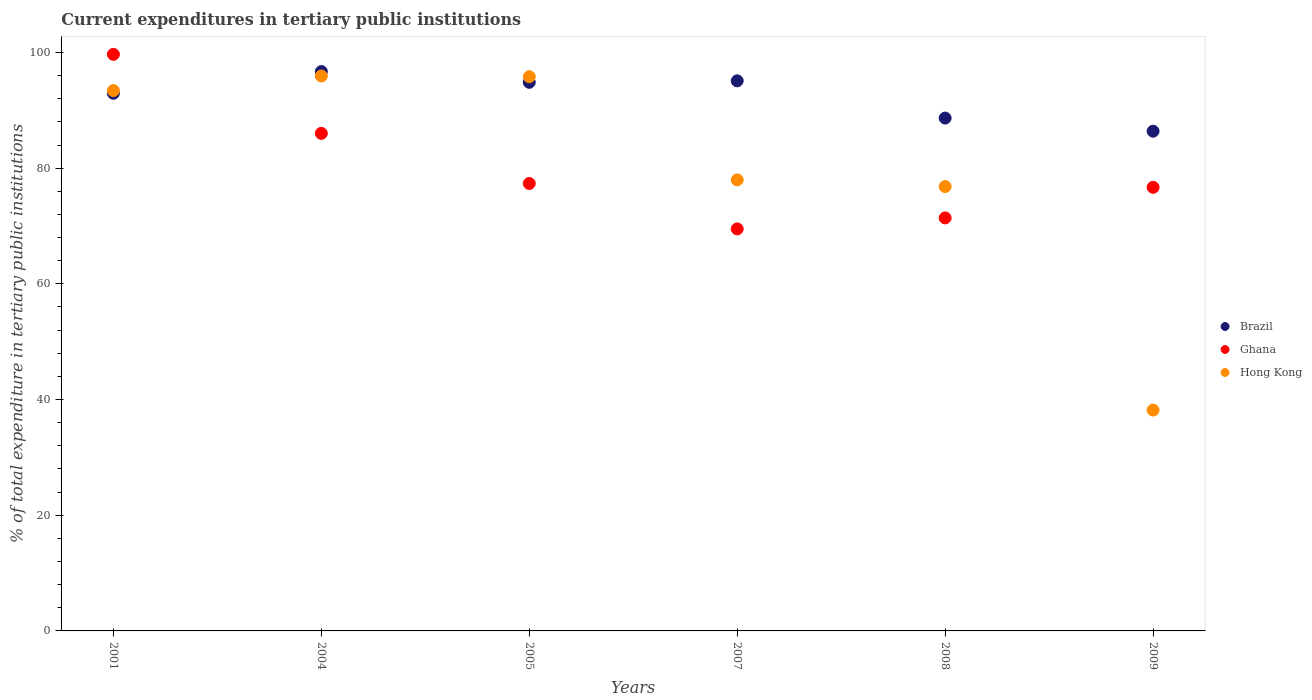What is the current expenditures in tertiary public institutions in Brazil in 2009?
Keep it short and to the point. 86.39. Across all years, what is the maximum current expenditures in tertiary public institutions in Ghana?
Offer a terse response. 99.67. Across all years, what is the minimum current expenditures in tertiary public institutions in Hong Kong?
Provide a short and direct response. 38.18. In which year was the current expenditures in tertiary public institutions in Brazil maximum?
Offer a terse response. 2004. In which year was the current expenditures in tertiary public institutions in Brazil minimum?
Ensure brevity in your answer.  2009. What is the total current expenditures in tertiary public institutions in Brazil in the graph?
Your answer should be very brief. 554.61. What is the difference between the current expenditures in tertiary public institutions in Ghana in 2004 and that in 2008?
Make the answer very short. 14.61. What is the difference between the current expenditures in tertiary public institutions in Hong Kong in 2008 and the current expenditures in tertiary public institutions in Brazil in 2009?
Ensure brevity in your answer.  -9.57. What is the average current expenditures in tertiary public institutions in Ghana per year?
Give a very brief answer. 80.1. In the year 2004, what is the difference between the current expenditures in tertiary public institutions in Hong Kong and current expenditures in tertiary public institutions in Ghana?
Your response must be concise. 9.92. In how many years, is the current expenditures in tertiary public institutions in Hong Kong greater than 28 %?
Your answer should be compact. 6. What is the ratio of the current expenditures in tertiary public institutions in Hong Kong in 2004 to that in 2007?
Make the answer very short. 1.23. Is the current expenditures in tertiary public institutions in Hong Kong in 2001 less than that in 2007?
Your answer should be very brief. No. Is the difference between the current expenditures in tertiary public institutions in Hong Kong in 2001 and 2004 greater than the difference between the current expenditures in tertiary public institutions in Ghana in 2001 and 2004?
Offer a very short reply. No. What is the difference between the highest and the second highest current expenditures in tertiary public institutions in Hong Kong?
Provide a succinct answer. 0.13. What is the difference between the highest and the lowest current expenditures in tertiary public institutions in Hong Kong?
Offer a very short reply. 57.75. In how many years, is the current expenditures in tertiary public institutions in Brazil greater than the average current expenditures in tertiary public institutions in Brazil taken over all years?
Offer a very short reply. 4. Is the sum of the current expenditures in tertiary public institutions in Hong Kong in 2001 and 2004 greater than the maximum current expenditures in tertiary public institutions in Brazil across all years?
Keep it short and to the point. Yes. Does the current expenditures in tertiary public institutions in Hong Kong monotonically increase over the years?
Your answer should be compact. No. Is the current expenditures in tertiary public institutions in Hong Kong strictly greater than the current expenditures in tertiary public institutions in Ghana over the years?
Your answer should be compact. No. Is the current expenditures in tertiary public institutions in Hong Kong strictly less than the current expenditures in tertiary public institutions in Brazil over the years?
Keep it short and to the point. No. How many years are there in the graph?
Offer a very short reply. 6. What is the difference between two consecutive major ticks on the Y-axis?
Provide a succinct answer. 20. Does the graph contain grids?
Make the answer very short. No. How many legend labels are there?
Ensure brevity in your answer.  3. What is the title of the graph?
Keep it short and to the point. Current expenditures in tertiary public institutions. Does "New Caledonia" appear as one of the legend labels in the graph?
Ensure brevity in your answer.  No. What is the label or title of the Y-axis?
Provide a short and direct response. % of total expenditure in tertiary public institutions. What is the % of total expenditure in tertiary public institutions in Brazil in 2001?
Provide a succinct answer. 92.94. What is the % of total expenditure in tertiary public institutions of Ghana in 2001?
Your answer should be compact. 99.67. What is the % of total expenditure in tertiary public institutions of Hong Kong in 2001?
Make the answer very short. 93.41. What is the % of total expenditure in tertiary public institutions in Brazil in 2004?
Ensure brevity in your answer.  96.7. What is the % of total expenditure in tertiary public institutions in Ghana in 2004?
Provide a short and direct response. 86.01. What is the % of total expenditure in tertiary public institutions in Hong Kong in 2004?
Ensure brevity in your answer.  95.93. What is the % of total expenditure in tertiary public institutions in Brazil in 2005?
Offer a very short reply. 94.84. What is the % of total expenditure in tertiary public institutions of Ghana in 2005?
Keep it short and to the point. 77.35. What is the % of total expenditure in tertiary public institutions of Hong Kong in 2005?
Provide a short and direct response. 95.81. What is the % of total expenditure in tertiary public institutions in Brazil in 2007?
Keep it short and to the point. 95.09. What is the % of total expenditure in tertiary public institutions in Ghana in 2007?
Ensure brevity in your answer.  69.49. What is the % of total expenditure in tertiary public institutions in Hong Kong in 2007?
Provide a short and direct response. 77.98. What is the % of total expenditure in tertiary public institutions of Brazil in 2008?
Make the answer very short. 88.65. What is the % of total expenditure in tertiary public institutions in Ghana in 2008?
Give a very brief answer. 71.4. What is the % of total expenditure in tertiary public institutions of Hong Kong in 2008?
Ensure brevity in your answer.  76.82. What is the % of total expenditure in tertiary public institutions of Brazil in 2009?
Your response must be concise. 86.39. What is the % of total expenditure in tertiary public institutions in Ghana in 2009?
Ensure brevity in your answer.  76.69. What is the % of total expenditure in tertiary public institutions of Hong Kong in 2009?
Ensure brevity in your answer.  38.18. Across all years, what is the maximum % of total expenditure in tertiary public institutions in Brazil?
Make the answer very short. 96.7. Across all years, what is the maximum % of total expenditure in tertiary public institutions in Ghana?
Provide a succinct answer. 99.67. Across all years, what is the maximum % of total expenditure in tertiary public institutions in Hong Kong?
Your response must be concise. 95.93. Across all years, what is the minimum % of total expenditure in tertiary public institutions in Brazil?
Ensure brevity in your answer.  86.39. Across all years, what is the minimum % of total expenditure in tertiary public institutions in Ghana?
Your answer should be compact. 69.49. Across all years, what is the minimum % of total expenditure in tertiary public institutions in Hong Kong?
Your response must be concise. 38.18. What is the total % of total expenditure in tertiary public institutions of Brazil in the graph?
Give a very brief answer. 554.61. What is the total % of total expenditure in tertiary public institutions in Ghana in the graph?
Your answer should be very brief. 480.62. What is the total % of total expenditure in tertiary public institutions in Hong Kong in the graph?
Ensure brevity in your answer.  478.12. What is the difference between the % of total expenditure in tertiary public institutions in Brazil in 2001 and that in 2004?
Ensure brevity in your answer.  -3.76. What is the difference between the % of total expenditure in tertiary public institutions in Ghana in 2001 and that in 2004?
Offer a terse response. 13.66. What is the difference between the % of total expenditure in tertiary public institutions of Hong Kong in 2001 and that in 2004?
Make the answer very short. -2.53. What is the difference between the % of total expenditure in tertiary public institutions of Brazil in 2001 and that in 2005?
Give a very brief answer. -1.9. What is the difference between the % of total expenditure in tertiary public institutions of Ghana in 2001 and that in 2005?
Your answer should be very brief. 22.32. What is the difference between the % of total expenditure in tertiary public institutions in Hong Kong in 2001 and that in 2005?
Your answer should be very brief. -2.4. What is the difference between the % of total expenditure in tertiary public institutions of Brazil in 2001 and that in 2007?
Offer a very short reply. -2.15. What is the difference between the % of total expenditure in tertiary public institutions of Ghana in 2001 and that in 2007?
Your answer should be very brief. 30.18. What is the difference between the % of total expenditure in tertiary public institutions of Hong Kong in 2001 and that in 2007?
Provide a short and direct response. 15.43. What is the difference between the % of total expenditure in tertiary public institutions in Brazil in 2001 and that in 2008?
Make the answer very short. 4.29. What is the difference between the % of total expenditure in tertiary public institutions of Ghana in 2001 and that in 2008?
Offer a very short reply. 28.27. What is the difference between the % of total expenditure in tertiary public institutions of Hong Kong in 2001 and that in 2008?
Your answer should be very brief. 16.59. What is the difference between the % of total expenditure in tertiary public institutions in Brazil in 2001 and that in 2009?
Offer a very short reply. 6.55. What is the difference between the % of total expenditure in tertiary public institutions in Ghana in 2001 and that in 2009?
Provide a succinct answer. 22.98. What is the difference between the % of total expenditure in tertiary public institutions of Hong Kong in 2001 and that in 2009?
Your answer should be compact. 55.22. What is the difference between the % of total expenditure in tertiary public institutions of Brazil in 2004 and that in 2005?
Keep it short and to the point. 1.86. What is the difference between the % of total expenditure in tertiary public institutions of Ghana in 2004 and that in 2005?
Ensure brevity in your answer.  8.66. What is the difference between the % of total expenditure in tertiary public institutions of Hong Kong in 2004 and that in 2005?
Give a very brief answer. 0.13. What is the difference between the % of total expenditure in tertiary public institutions of Brazil in 2004 and that in 2007?
Provide a succinct answer. 1.6. What is the difference between the % of total expenditure in tertiary public institutions in Ghana in 2004 and that in 2007?
Your response must be concise. 16.52. What is the difference between the % of total expenditure in tertiary public institutions in Hong Kong in 2004 and that in 2007?
Offer a very short reply. 17.96. What is the difference between the % of total expenditure in tertiary public institutions of Brazil in 2004 and that in 2008?
Offer a terse response. 8.04. What is the difference between the % of total expenditure in tertiary public institutions of Ghana in 2004 and that in 2008?
Ensure brevity in your answer.  14.61. What is the difference between the % of total expenditure in tertiary public institutions of Hong Kong in 2004 and that in 2008?
Make the answer very short. 19.11. What is the difference between the % of total expenditure in tertiary public institutions of Brazil in 2004 and that in 2009?
Your answer should be compact. 10.31. What is the difference between the % of total expenditure in tertiary public institutions of Ghana in 2004 and that in 2009?
Provide a short and direct response. 9.33. What is the difference between the % of total expenditure in tertiary public institutions in Hong Kong in 2004 and that in 2009?
Your answer should be compact. 57.75. What is the difference between the % of total expenditure in tertiary public institutions in Brazil in 2005 and that in 2007?
Provide a short and direct response. -0.25. What is the difference between the % of total expenditure in tertiary public institutions in Ghana in 2005 and that in 2007?
Make the answer very short. 7.86. What is the difference between the % of total expenditure in tertiary public institutions in Hong Kong in 2005 and that in 2007?
Your answer should be compact. 17.83. What is the difference between the % of total expenditure in tertiary public institutions of Brazil in 2005 and that in 2008?
Ensure brevity in your answer.  6.18. What is the difference between the % of total expenditure in tertiary public institutions of Ghana in 2005 and that in 2008?
Ensure brevity in your answer.  5.95. What is the difference between the % of total expenditure in tertiary public institutions in Hong Kong in 2005 and that in 2008?
Your answer should be very brief. 18.99. What is the difference between the % of total expenditure in tertiary public institutions of Brazil in 2005 and that in 2009?
Keep it short and to the point. 8.45. What is the difference between the % of total expenditure in tertiary public institutions of Ghana in 2005 and that in 2009?
Ensure brevity in your answer.  0.67. What is the difference between the % of total expenditure in tertiary public institutions of Hong Kong in 2005 and that in 2009?
Give a very brief answer. 57.63. What is the difference between the % of total expenditure in tertiary public institutions of Brazil in 2007 and that in 2008?
Your answer should be compact. 6.44. What is the difference between the % of total expenditure in tertiary public institutions in Ghana in 2007 and that in 2008?
Ensure brevity in your answer.  -1.91. What is the difference between the % of total expenditure in tertiary public institutions of Hong Kong in 2007 and that in 2008?
Your answer should be compact. 1.16. What is the difference between the % of total expenditure in tertiary public institutions of Brazil in 2007 and that in 2009?
Make the answer very short. 8.71. What is the difference between the % of total expenditure in tertiary public institutions in Ghana in 2007 and that in 2009?
Make the answer very short. -7.19. What is the difference between the % of total expenditure in tertiary public institutions of Hong Kong in 2007 and that in 2009?
Give a very brief answer. 39.79. What is the difference between the % of total expenditure in tertiary public institutions in Brazil in 2008 and that in 2009?
Provide a short and direct response. 2.27. What is the difference between the % of total expenditure in tertiary public institutions in Ghana in 2008 and that in 2009?
Your response must be concise. -5.29. What is the difference between the % of total expenditure in tertiary public institutions in Hong Kong in 2008 and that in 2009?
Provide a succinct answer. 38.64. What is the difference between the % of total expenditure in tertiary public institutions of Brazil in 2001 and the % of total expenditure in tertiary public institutions of Ghana in 2004?
Make the answer very short. 6.93. What is the difference between the % of total expenditure in tertiary public institutions in Brazil in 2001 and the % of total expenditure in tertiary public institutions in Hong Kong in 2004?
Provide a succinct answer. -2.99. What is the difference between the % of total expenditure in tertiary public institutions in Ghana in 2001 and the % of total expenditure in tertiary public institutions in Hong Kong in 2004?
Offer a very short reply. 3.74. What is the difference between the % of total expenditure in tertiary public institutions of Brazil in 2001 and the % of total expenditure in tertiary public institutions of Ghana in 2005?
Ensure brevity in your answer.  15.59. What is the difference between the % of total expenditure in tertiary public institutions in Brazil in 2001 and the % of total expenditure in tertiary public institutions in Hong Kong in 2005?
Make the answer very short. -2.87. What is the difference between the % of total expenditure in tertiary public institutions of Ghana in 2001 and the % of total expenditure in tertiary public institutions of Hong Kong in 2005?
Offer a very short reply. 3.86. What is the difference between the % of total expenditure in tertiary public institutions of Brazil in 2001 and the % of total expenditure in tertiary public institutions of Ghana in 2007?
Make the answer very short. 23.45. What is the difference between the % of total expenditure in tertiary public institutions of Brazil in 2001 and the % of total expenditure in tertiary public institutions of Hong Kong in 2007?
Offer a terse response. 14.97. What is the difference between the % of total expenditure in tertiary public institutions of Ghana in 2001 and the % of total expenditure in tertiary public institutions of Hong Kong in 2007?
Provide a short and direct response. 21.7. What is the difference between the % of total expenditure in tertiary public institutions of Brazil in 2001 and the % of total expenditure in tertiary public institutions of Ghana in 2008?
Keep it short and to the point. 21.54. What is the difference between the % of total expenditure in tertiary public institutions of Brazil in 2001 and the % of total expenditure in tertiary public institutions of Hong Kong in 2008?
Your answer should be very brief. 16.12. What is the difference between the % of total expenditure in tertiary public institutions in Ghana in 2001 and the % of total expenditure in tertiary public institutions in Hong Kong in 2008?
Provide a succinct answer. 22.85. What is the difference between the % of total expenditure in tertiary public institutions of Brazil in 2001 and the % of total expenditure in tertiary public institutions of Ghana in 2009?
Provide a short and direct response. 16.25. What is the difference between the % of total expenditure in tertiary public institutions of Brazil in 2001 and the % of total expenditure in tertiary public institutions of Hong Kong in 2009?
Offer a very short reply. 54.76. What is the difference between the % of total expenditure in tertiary public institutions in Ghana in 2001 and the % of total expenditure in tertiary public institutions in Hong Kong in 2009?
Offer a very short reply. 61.49. What is the difference between the % of total expenditure in tertiary public institutions in Brazil in 2004 and the % of total expenditure in tertiary public institutions in Ghana in 2005?
Your response must be concise. 19.34. What is the difference between the % of total expenditure in tertiary public institutions of Brazil in 2004 and the % of total expenditure in tertiary public institutions of Hong Kong in 2005?
Your answer should be very brief. 0.89. What is the difference between the % of total expenditure in tertiary public institutions in Ghana in 2004 and the % of total expenditure in tertiary public institutions in Hong Kong in 2005?
Your answer should be compact. -9.79. What is the difference between the % of total expenditure in tertiary public institutions of Brazil in 2004 and the % of total expenditure in tertiary public institutions of Ghana in 2007?
Give a very brief answer. 27.2. What is the difference between the % of total expenditure in tertiary public institutions of Brazil in 2004 and the % of total expenditure in tertiary public institutions of Hong Kong in 2007?
Make the answer very short. 18.72. What is the difference between the % of total expenditure in tertiary public institutions in Ghana in 2004 and the % of total expenditure in tertiary public institutions in Hong Kong in 2007?
Keep it short and to the point. 8.04. What is the difference between the % of total expenditure in tertiary public institutions in Brazil in 2004 and the % of total expenditure in tertiary public institutions in Ghana in 2008?
Offer a very short reply. 25.3. What is the difference between the % of total expenditure in tertiary public institutions in Brazil in 2004 and the % of total expenditure in tertiary public institutions in Hong Kong in 2008?
Make the answer very short. 19.88. What is the difference between the % of total expenditure in tertiary public institutions in Ghana in 2004 and the % of total expenditure in tertiary public institutions in Hong Kong in 2008?
Give a very brief answer. 9.2. What is the difference between the % of total expenditure in tertiary public institutions in Brazil in 2004 and the % of total expenditure in tertiary public institutions in Ghana in 2009?
Offer a terse response. 20.01. What is the difference between the % of total expenditure in tertiary public institutions of Brazil in 2004 and the % of total expenditure in tertiary public institutions of Hong Kong in 2009?
Offer a terse response. 58.51. What is the difference between the % of total expenditure in tertiary public institutions in Ghana in 2004 and the % of total expenditure in tertiary public institutions in Hong Kong in 2009?
Give a very brief answer. 47.83. What is the difference between the % of total expenditure in tertiary public institutions of Brazil in 2005 and the % of total expenditure in tertiary public institutions of Ghana in 2007?
Your response must be concise. 25.35. What is the difference between the % of total expenditure in tertiary public institutions in Brazil in 2005 and the % of total expenditure in tertiary public institutions in Hong Kong in 2007?
Your response must be concise. 16.86. What is the difference between the % of total expenditure in tertiary public institutions of Ghana in 2005 and the % of total expenditure in tertiary public institutions of Hong Kong in 2007?
Keep it short and to the point. -0.62. What is the difference between the % of total expenditure in tertiary public institutions of Brazil in 2005 and the % of total expenditure in tertiary public institutions of Ghana in 2008?
Ensure brevity in your answer.  23.44. What is the difference between the % of total expenditure in tertiary public institutions in Brazil in 2005 and the % of total expenditure in tertiary public institutions in Hong Kong in 2008?
Provide a succinct answer. 18.02. What is the difference between the % of total expenditure in tertiary public institutions of Ghana in 2005 and the % of total expenditure in tertiary public institutions of Hong Kong in 2008?
Your response must be concise. 0.54. What is the difference between the % of total expenditure in tertiary public institutions of Brazil in 2005 and the % of total expenditure in tertiary public institutions of Ghana in 2009?
Your answer should be compact. 18.15. What is the difference between the % of total expenditure in tertiary public institutions in Brazil in 2005 and the % of total expenditure in tertiary public institutions in Hong Kong in 2009?
Your answer should be very brief. 56.66. What is the difference between the % of total expenditure in tertiary public institutions in Ghana in 2005 and the % of total expenditure in tertiary public institutions in Hong Kong in 2009?
Your response must be concise. 39.17. What is the difference between the % of total expenditure in tertiary public institutions of Brazil in 2007 and the % of total expenditure in tertiary public institutions of Ghana in 2008?
Provide a short and direct response. 23.69. What is the difference between the % of total expenditure in tertiary public institutions in Brazil in 2007 and the % of total expenditure in tertiary public institutions in Hong Kong in 2008?
Keep it short and to the point. 18.28. What is the difference between the % of total expenditure in tertiary public institutions in Ghana in 2007 and the % of total expenditure in tertiary public institutions in Hong Kong in 2008?
Offer a very short reply. -7.32. What is the difference between the % of total expenditure in tertiary public institutions in Brazil in 2007 and the % of total expenditure in tertiary public institutions in Ghana in 2009?
Your answer should be very brief. 18.41. What is the difference between the % of total expenditure in tertiary public institutions of Brazil in 2007 and the % of total expenditure in tertiary public institutions of Hong Kong in 2009?
Provide a short and direct response. 56.91. What is the difference between the % of total expenditure in tertiary public institutions in Ghana in 2007 and the % of total expenditure in tertiary public institutions in Hong Kong in 2009?
Give a very brief answer. 31.31. What is the difference between the % of total expenditure in tertiary public institutions in Brazil in 2008 and the % of total expenditure in tertiary public institutions in Ghana in 2009?
Keep it short and to the point. 11.97. What is the difference between the % of total expenditure in tertiary public institutions of Brazil in 2008 and the % of total expenditure in tertiary public institutions of Hong Kong in 2009?
Your answer should be very brief. 50.47. What is the difference between the % of total expenditure in tertiary public institutions in Ghana in 2008 and the % of total expenditure in tertiary public institutions in Hong Kong in 2009?
Your answer should be very brief. 33.22. What is the average % of total expenditure in tertiary public institutions in Brazil per year?
Your answer should be compact. 92.44. What is the average % of total expenditure in tertiary public institutions of Ghana per year?
Your answer should be compact. 80.1. What is the average % of total expenditure in tertiary public institutions of Hong Kong per year?
Your answer should be very brief. 79.69. In the year 2001, what is the difference between the % of total expenditure in tertiary public institutions of Brazil and % of total expenditure in tertiary public institutions of Ghana?
Make the answer very short. -6.73. In the year 2001, what is the difference between the % of total expenditure in tertiary public institutions in Brazil and % of total expenditure in tertiary public institutions in Hong Kong?
Your answer should be very brief. -0.46. In the year 2001, what is the difference between the % of total expenditure in tertiary public institutions of Ghana and % of total expenditure in tertiary public institutions of Hong Kong?
Your answer should be very brief. 6.27. In the year 2004, what is the difference between the % of total expenditure in tertiary public institutions of Brazil and % of total expenditure in tertiary public institutions of Ghana?
Your answer should be compact. 10.68. In the year 2004, what is the difference between the % of total expenditure in tertiary public institutions in Brazil and % of total expenditure in tertiary public institutions in Hong Kong?
Provide a succinct answer. 0.76. In the year 2004, what is the difference between the % of total expenditure in tertiary public institutions in Ghana and % of total expenditure in tertiary public institutions in Hong Kong?
Offer a very short reply. -9.92. In the year 2005, what is the difference between the % of total expenditure in tertiary public institutions of Brazil and % of total expenditure in tertiary public institutions of Ghana?
Your answer should be very brief. 17.49. In the year 2005, what is the difference between the % of total expenditure in tertiary public institutions of Brazil and % of total expenditure in tertiary public institutions of Hong Kong?
Your response must be concise. -0.97. In the year 2005, what is the difference between the % of total expenditure in tertiary public institutions in Ghana and % of total expenditure in tertiary public institutions in Hong Kong?
Keep it short and to the point. -18.45. In the year 2007, what is the difference between the % of total expenditure in tertiary public institutions of Brazil and % of total expenditure in tertiary public institutions of Ghana?
Offer a terse response. 25.6. In the year 2007, what is the difference between the % of total expenditure in tertiary public institutions in Brazil and % of total expenditure in tertiary public institutions in Hong Kong?
Make the answer very short. 17.12. In the year 2007, what is the difference between the % of total expenditure in tertiary public institutions in Ghana and % of total expenditure in tertiary public institutions in Hong Kong?
Provide a succinct answer. -8.48. In the year 2008, what is the difference between the % of total expenditure in tertiary public institutions in Brazil and % of total expenditure in tertiary public institutions in Ghana?
Make the answer very short. 17.25. In the year 2008, what is the difference between the % of total expenditure in tertiary public institutions of Brazil and % of total expenditure in tertiary public institutions of Hong Kong?
Give a very brief answer. 11.84. In the year 2008, what is the difference between the % of total expenditure in tertiary public institutions in Ghana and % of total expenditure in tertiary public institutions in Hong Kong?
Give a very brief answer. -5.42. In the year 2009, what is the difference between the % of total expenditure in tertiary public institutions of Brazil and % of total expenditure in tertiary public institutions of Ghana?
Make the answer very short. 9.7. In the year 2009, what is the difference between the % of total expenditure in tertiary public institutions of Brazil and % of total expenditure in tertiary public institutions of Hong Kong?
Offer a very short reply. 48.21. In the year 2009, what is the difference between the % of total expenditure in tertiary public institutions in Ghana and % of total expenditure in tertiary public institutions in Hong Kong?
Offer a terse response. 38.51. What is the ratio of the % of total expenditure in tertiary public institutions in Brazil in 2001 to that in 2004?
Your answer should be compact. 0.96. What is the ratio of the % of total expenditure in tertiary public institutions in Ghana in 2001 to that in 2004?
Make the answer very short. 1.16. What is the ratio of the % of total expenditure in tertiary public institutions in Hong Kong in 2001 to that in 2004?
Your answer should be compact. 0.97. What is the ratio of the % of total expenditure in tertiary public institutions of Brazil in 2001 to that in 2005?
Your response must be concise. 0.98. What is the ratio of the % of total expenditure in tertiary public institutions in Ghana in 2001 to that in 2005?
Offer a very short reply. 1.29. What is the ratio of the % of total expenditure in tertiary public institutions of Hong Kong in 2001 to that in 2005?
Ensure brevity in your answer.  0.97. What is the ratio of the % of total expenditure in tertiary public institutions of Brazil in 2001 to that in 2007?
Give a very brief answer. 0.98. What is the ratio of the % of total expenditure in tertiary public institutions in Ghana in 2001 to that in 2007?
Provide a succinct answer. 1.43. What is the ratio of the % of total expenditure in tertiary public institutions of Hong Kong in 2001 to that in 2007?
Give a very brief answer. 1.2. What is the ratio of the % of total expenditure in tertiary public institutions in Brazil in 2001 to that in 2008?
Give a very brief answer. 1.05. What is the ratio of the % of total expenditure in tertiary public institutions in Ghana in 2001 to that in 2008?
Provide a short and direct response. 1.4. What is the ratio of the % of total expenditure in tertiary public institutions in Hong Kong in 2001 to that in 2008?
Your answer should be very brief. 1.22. What is the ratio of the % of total expenditure in tertiary public institutions in Brazil in 2001 to that in 2009?
Your answer should be very brief. 1.08. What is the ratio of the % of total expenditure in tertiary public institutions in Ghana in 2001 to that in 2009?
Your answer should be compact. 1.3. What is the ratio of the % of total expenditure in tertiary public institutions in Hong Kong in 2001 to that in 2009?
Provide a short and direct response. 2.45. What is the ratio of the % of total expenditure in tertiary public institutions in Brazil in 2004 to that in 2005?
Give a very brief answer. 1.02. What is the ratio of the % of total expenditure in tertiary public institutions in Ghana in 2004 to that in 2005?
Your answer should be very brief. 1.11. What is the ratio of the % of total expenditure in tertiary public institutions in Hong Kong in 2004 to that in 2005?
Give a very brief answer. 1. What is the ratio of the % of total expenditure in tertiary public institutions of Brazil in 2004 to that in 2007?
Provide a short and direct response. 1.02. What is the ratio of the % of total expenditure in tertiary public institutions in Ghana in 2004 to that in 2007?
Keep it short and to the point. 1.24. What is the ratio of the % of total expenditure in tertiary public institutions of Hong Kong in 2004 to that in 2007?
Give a very brief answer. 1.23. What is the ratio of the % of total expenditure in tertiary public institutions of Brazil in 2004 to that in 2008?
Make the answer very short. 1.09. What is the ratio of the % of total expenditure in tertiary public institutions in Ghana in 2004 to that in 2008?
Keep it short and to the point. 1.2. What is the ratio of the % of total expenditure in tertiary public institutions in Hong Kong in 2004 to that in 2008?
Offer a terse response. 1.25. What is the ratio of the % of total expenditure in tertiary public institutions of Brazil in 2004 to that in 2009?
Your answer should be very brief. 1.12. What is the ratio of the % of total expenditure in tertiary public institutions in Ghana in 2004 to that in 2009?
Make the answer very short. 1.12. What is the ratio of the % of total expenditure in tertiary public institutions in Hong Kong in 2004 to that in 2009?
Make the answer very short. 2.51. What is the ratio of the % of total expenditure in tertiary public institutions in Brazil in 2005 to that in 2007?
Offer a terse response. 1. What is the ratio of the % of total expenditure in tertiary public institutions in Ghana in 2005 to that in 2007?
Give a very brief answer. 1.11. What is the ratio of the % of total expenditure in tertiary public institutions in Hong Kong in 2005 to that in 2007?
Your answer should be compact. 1.23. What is the ratio of the % of total expenditure in tertiary public institutions in Brazil in 2005 to that in 2008?
Offer a terse response. 1.07. What is the ratio of the % of total expenditure in tertiary public institutions of Ghana in 2005 to that in 2008?
Offer a very short reply. 1.08. What is the ratio of the % of total expenditure in tertiary public institutions in Hong Kong in 2005 to that in 2008?
Your answer should be very brief. 1.25. What is the ratio of the % of total expenditure in tertiary public institutions in Brazil in 2005 to that in 2009?
Give a very brief answer. 1.1. What is the ratio of the % of total expenditure in tertiary public institutions of Ghana in 2005 to that in 2009?
Keep it short and to the point. 1.01. What is the ratio of the % of total expenditure in tertiary public institutions of Hong Kong in 2005 to that in 2009?
Offer a very short reply. 2.51. What is the ratio of the % of total expenditure in tertiary public institutions in Brazil in 2007 to that in 2008?
Provide a short and direct response. 1.07. What is the ratio of the % of total expenditure in tertiary public institutions of Ghana in 2007 to that in 2008?
Provide a short and direct response. 0.97. What is the ratio of the % of total expenditure in tertiary public institutions of Hong Kong in 2007 to that in 2008?
Give a very brief answer. 1.02. What is the ratio of the % of total expenditure in tertiary public institutions of Brazil in 2007 to that in 2009?
Keep it short and to the point. 1.1. What is the ratio of the % of total expenditure in tertiary public institutions in Ghana in 2007 to that in 2009?
Offer a very short reply. 0.91. What is the ratio of the % of total expenditure in tertiary public institutions of Hong Kong in 2007 to that in 2009?
Keep it short and to the point. 2.04. What is the ratio of the % of total expenditure in tertiary public institutions in Brazil in 2008 to that in 2009?
Provide a short and direct response. 1.03. What is the ratio of the % of total expenditure in tertiary public institutions of Ghana in 2008 to that in 2009?
Give a very brief answer. 0.93. What is the ratio of the % of total expenditure in tertiary public institutions of Hong Kong in 2008 to that in 2009?
Offer a very short reply. 2.01. What is the difference between the highest and the second highest % of total expenditure in tertiary public institutions of Brazil?
Ensure brevity in your answer.  1.6. What is the difference between the highest and the second highest % of total expenditure in tertiary public institutions in Ghana?
Make the answer very short. 13.66. What is the difference between the highest and the second highest % of total expenditure in tertiary public institutions of Hong Kong?
Your response must be concise. 0.13. What is the difference between the highest and the lowest % of total expenditure in tertiary public institutions of Brazil?
Provide a short and direct response. 10.31. What is the difference between the highest and the lowest % of total expenditure in tertiary public institutions of Ghana?
Your answer should be compact. 30.18. What is the difference between the highest and the lowest % of total expenditure in tertiary public institutions of Hong Kong?
Keep it short and to the point. 57.75. 